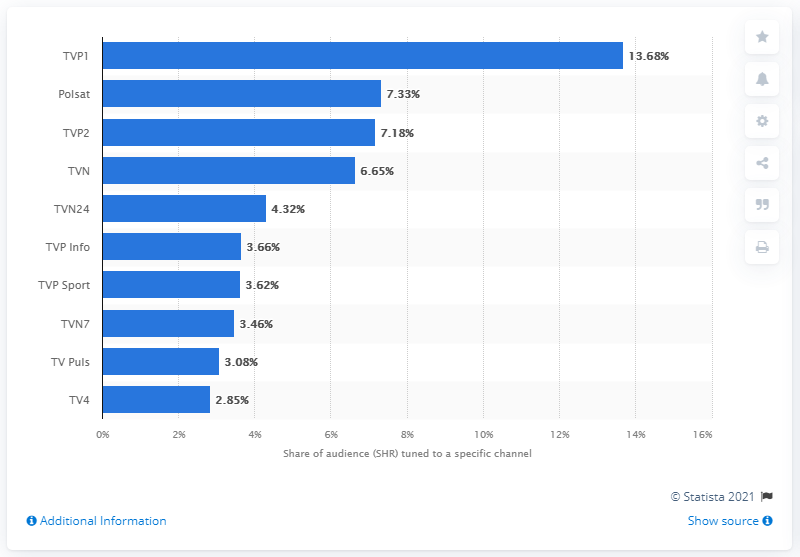Draw attention to some important aspects in this diagram. Polsat was the second most popular TV channel in Poland in June 2021. 